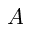<formula> <loc_0><loc_0><loc_500><loc_500>A</formula> 